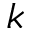<formula> <loc_0><loc_0><loc_500><loc_500>k</formula> 